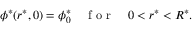<formula> <loc_0><loc_0><loc_500><loc_500>\phi ^ { * } ( r ^ { * } , 0 ) = \phi _ { 0 } ^ { * } \quad f o r \quad 0 < r ^ { * } < R ^ { * } .</formula> 